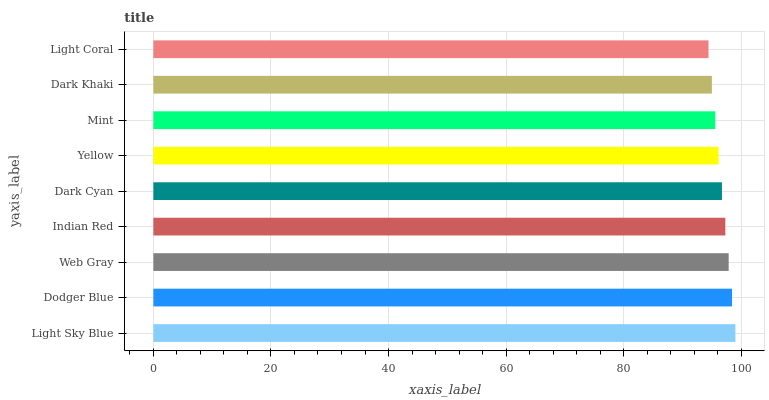Is Light Coral the minimum?
Answer yes or no. Yes. Is Light Sky Blue the maximum?
Answer yes or no. Yes. Is Dodger Blue the minimum?
Answer yes or no. No. Is Dodger Blue the maximum?
Answer yes or no. No. Is Light Sky Blue greater than Dodger Blue?
Answer yes or no. Yes. Is Dodger Blue less than Light Sky Blue?
Answer yes or no. Yes. Is Dodger Blue greater than Light Sky Blue?
Answer yes or no. No. Is Light Sky Blue less than Dodger Blue?
Answer yes or no. No. Is Dark Cyan the high median?
Answer yes or no. Yes. Is Dark Cyan the low median?
Answer yes or no. Yes. Is Light Sky Blue the high median?
Answer yes or no. No. Is Dark Khaki the low median?
Answer yes or no. No. 